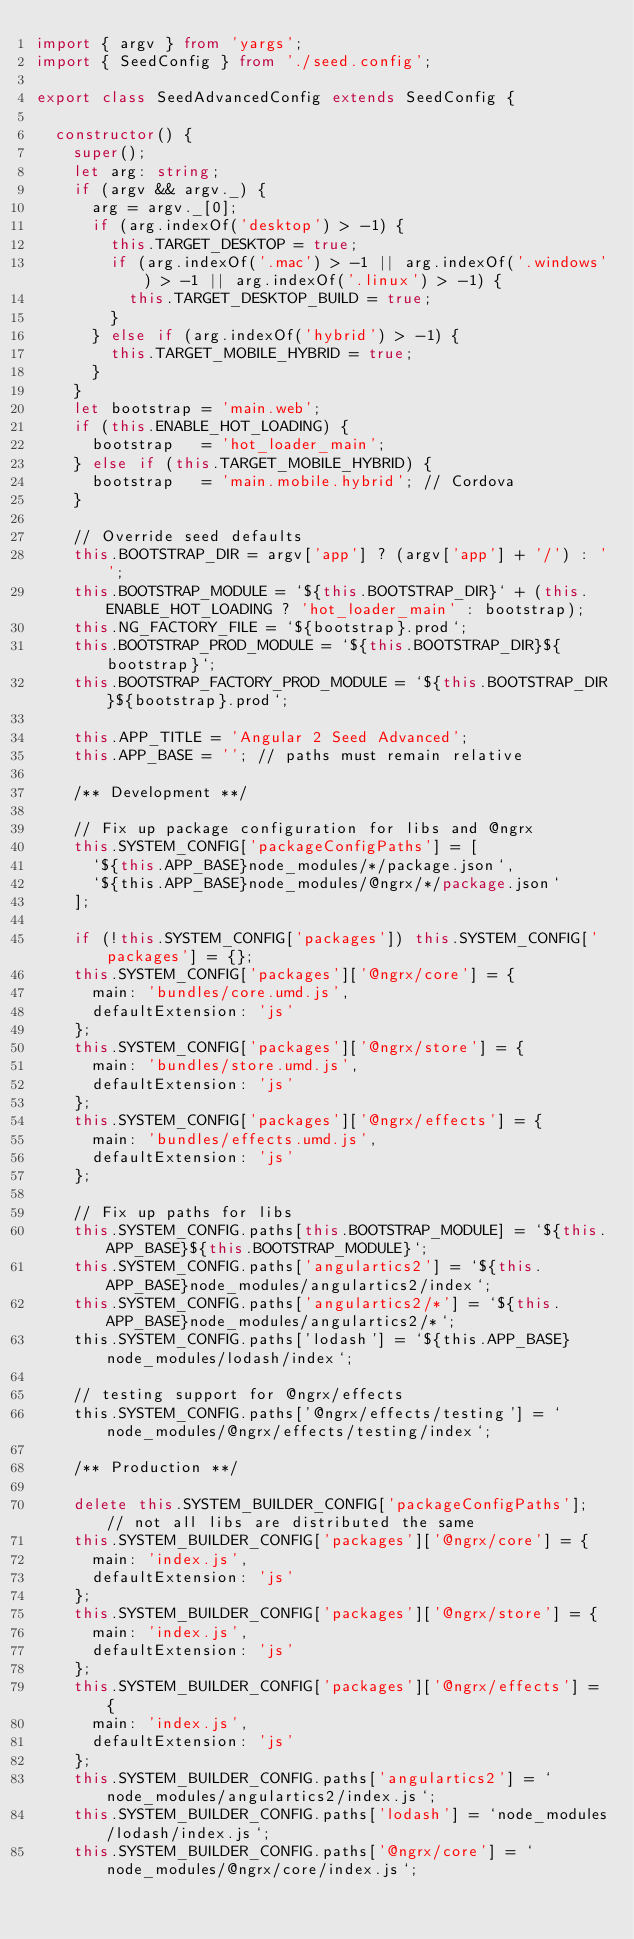Convert code to text. <code><loc_0><loc_0><loc_500><loc_500><_TypeScript_>import { argv } from 'yargs';
import { SeedConfig } from './seed.config';

export class SeedAdvancedConfig extends SeedConfig {

  constructor() {
    super();
    let arg: string;
    if (argv && argv._) {
      arg = argv._[0];
      if (arg.indexOf('desktop') > -1) {
        this.TARGET_DESKTOP = true;
        if (arg.indexOf('.mac') > -1 || arg.indexOf('.windows') > -1 || arg.indexOf('.linux') > -1) {
          this.TARGET_DESKTOP_BUILD = true;
        }
      } else if (arg.indexOf('hybrid') > -1) {
        this.TARGET_MOBILE_HYBRID = true;
      }
    }
    let bootstrap = 'main.web';
    if (this.ENABLE_HOT_LOADING) {
      bootstrap   = 'hot_loader_main';
    } else if (this.TARGET_MOBILE_HYBRID) {
      bootstrap   = 'main.mobile.hybrid'; // Cordova
    }

    // Override seed defaults
    this.BOOTSTRAP_DIR = argv['app'] ? (argv['app'] + '/') : '';
    this.BOOTSTRAP_MODULE = `${this.BOOTSTRAP_DIR}` + (this.ENABLE_HOT_LOADING ? 'hot_loader_main' : bootstrap);
    this.NG_FACTORY_FILE = `${bootstrap}.prod`;
    this.BOOTSTRAP_PROD_MODULE = `${this.BOOTSTRAP_DIR}${bootstrap}`;
    this.BOOTSTRAP_FACTORY_PROD_MODULE = `${this.BOOTSTRAP_DIR}${bootstrap}.prod`;

    this.APP_TITLE = 'Angular 2 Seed Advanced';
    this.APP_BASE = ''; // paths must remain relative

    /** Development **/

    // Fix up package configuration for libs and @ngrx
    this.SYSTEM_CONFIG['packageConfigPaths'] = [
      `${this.APP_BASE}node_modules/*/package.json`,
      `${this.APP_BASE}node_modules/@ngrx/*/package.json`
    ];

    if (!this.SYSTEM_CONFIG['packages']) this.SYSTEM_CONFIG['packages'] = {};
    this.SYSTEM_CONFIG['packages']['@ngrx/core'] = {
      main: 'bundles/core.umd.js',
      defaultExtension: 'js'
    };
    this.SYSTEM_CONFIG['packages']['@ngrx/store'] = {
      main: 'bundles/store.umd.js',
      defaultExtension: 'js'
    };
    this.SYSTEM_CONFIG['packages']['@ngrx/effects'] = {
      main: 'bundles/effects.umd.js',
      defaultExtension: 'js'
    };

    // Fix up paths for libs
    this.SYSTEM_CONFIG.paths[this.BOOTSTRAP_MODULE] = `${this.APP_BASE}${this.BOOTSTRAP_MODULE}`;
    this.SYSTEM_CONFIG.paths['angulartics2'] = `${this.APP_BASE}node_modules/angulartics2/index`;
    this.SYSTEM_CONFIG.paths['angulartics2/*'] = `${this.APP_BASE}node_modules/angulartics2/*`;
    this.SYSTEM_CONFIG.paths['lodash'] = `${this.APP_BASE}node_modules/lodash/index`;

    // testing support for @ngrx/effects
    this.SYSTEM_CONFIG.paths['@ngrx/effects/testing'] = `node_modules/@ngrx/effects/testing/index`;

    /** Production **/

    delete this.SYSTEM_BUILDER_CONFIG['packageConfigPaths']; // not all libs are distributed the same
    this.SYSTEM_BUILDER_CONFIG['packages']['@ngrx/core'] = {
      main: 'index.js',
      defaultExtension: 'js'
    };
    this.SYSTEM_BUILDER_CONFIG['packages']['@ngrx/store'] = {
      main: 'index.js',
      defaultExtension: 'js'
    };
    this.SYSTEM_BUILDER_CONFIG['packages']['@ngrx/effects'] = {
      main: 'index.js',
      defaultExtension: 'js'
    };
    this.SYSTEM_BUILDER_CONFIG.paths['angulartics2'] = `node_modules/angulartics2/index.js`;
    this.SYSTEM_BUILDER_CONFIG.paths['lodash'] = `node_modules/lodash/index.js`;
    this.SYSTEM_BUILDER_CONFIG.paths['@ngrx/core'] = `node_modules/@ngrx/core/index.js`;</code> 